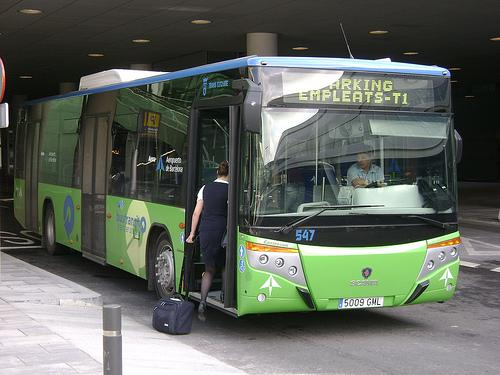Identify the action performed by a woman concerning a bus. A woman is boarding the bus. Mention an object on the ground near the bus and describe its color. There is a dark luggage on the street near the bus. What are the colors of the dress a woman is wearing? The woman is wearing a blue dress. What does the number 547 signify in the image? The number 547 possibly represents the bus number shown on the side of the bus. List the colors and types of signals found on the bus. The bus has a right turn signal, a left turn signal, and a blue number. The signals are yellow or amber. Describe the position and appearance of a man related to the bus. A man is sitting at the wheel of the green bus, possibly the bus driver. Explain what kind of vehicle is in the image and describe its color. There is a large green city bus in the image. Examine the image and describe the bags found in it. There are black bags with long handles, a blue bag, and a black back pack by the window. What type of license plate is on the bus, and what are its colors? There is a white and black license plate on the bus. Mention the objects found around the middle section of the bus. In the middle section of the bus, we find doors, a window, and a black back pack located by the window. Find the color and position of the license plate on the bus. White and black license plate, X:335 Y:290 Width:55 Height:55. In the image, identify the object that has a similar sentence to "a woman wearing a black dress." A woman wearing a blue dress. Can you see a dog sitting next to the dark luggage on the street? No, it's not mentioned in the image. Which type of bag is present in the image? A black bag with a long handle. What color is the number on the bus? Blue What objects can be found near the middle doors of the bus? A black backpack by the window. Analyze the interactions between objects in the image. A woman is boarding the bus, and a man is sitting behind the wheel. Is there any unusual detail in the image? No obvious anomaly detected. Are the pants of the woman blue or black? The woman has blue pants. What type of signal is on the right side of the bus? Right turn signal of the bus. Identify the presence or absence of a bag of luggage. A bag of luggage is present. Describe the color and type of the bus. The bus is large, green and city. Which vehicle's part is attached to its front? A white and black license plate. What type of luggage is on the street? Dark luggage on the street. Determine the location and dimensions of the green LCD screen on the bus. Green LCD screen on the bus is at X:293 Y:68, Width:143 Height:143. State the sentiment evoked by the image. The sentiment is neutral. Assess the quality of the bus image. The image quality is high. Read the number on the bus. 547 